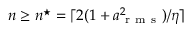<formula> <loc_0><loc_0><loc_500><loc_500>n \geq n ^ { ^ { * } } = \lceil 2 ( 1 + a _ { r m s } ^ { 2 } ) / \eta \rceil</formula> 